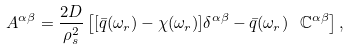<formula> <loc_0><loc_0><loc_500><loc_500>A ^ { \alpha \beta } = \frac { 2 D } { \rho ^ { 2 } _ { s } } \left [ [ \bar { q } ( \omega _ { r } ) - \chi ( \omega _ { r } ) ] \delta ^ { \alpha \beta } - \bar { q } ( \omega _ { r } ) \ \mathbb { C } ^ { \alpha \beta } \right ] ,</formula> 